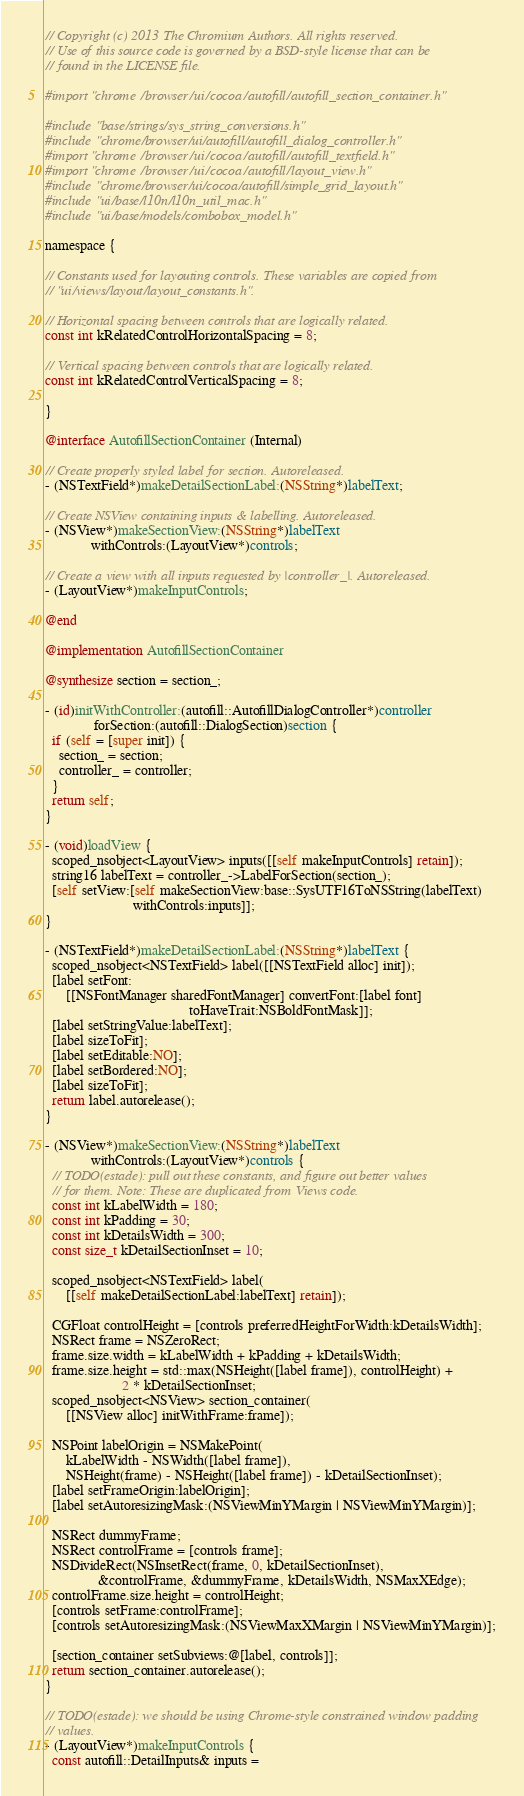Convert code to text. <code><loc_0><loc_0><loc_500><loc_500><_ObjectiveC_>// Copyright (c) 2013 The Chromium Authors. All rights reserved.
// Use of this source code is governed by a BSD-style license that can be
// found in the LICENSE file.

#import "chrome/browser/ui/cocoa/autofill/autofill_section_container.h"

#include "base/strings/sys_string_conversions.h"
#include "chrome/browser/ui/autofill/autofill_dialog_controller.h"
#import "chrome/browser/ui/cocoa/autofill/autofill_textfield.h"
#import "chrome/browser/ui/cocoa/autofill/layout_view.h"
#include "chrome/browser/ui/cocoa/autofill/simple_grid_layout.h"
#include "ui/base/l10n/l10n_util_mac.h"
#include "ui/base/models/combobox_model.h"

namespace {

// Constants used for layouting controls. These variables are copied from
// "ui/views/layout/layout_constants.h".

// Horizontal spacing between controls that are logically related.
const int kRelatedControlHorizontalSpacing = 8;

// Vertical spacing between controls that are logically related.
const int kRelatedControlVerticalSpacing = 8;

}

@interface AutofillSectionContainer (Internal)

// Create properly styled label for section. Autoreleased.
- (NSTextField*)makeDetailSectionLabel:(NSString*)labelText;

// Create NSView containing inputs & labelling. Autoreleased.
- (NSView*)makeSectionView:(NSString*)labelText
             withControls:(LayoutView*)controls;

// Create a view with all inputs requested by |controller_|. Autoreleased.
- (LayoutView*)makeInputControls;

@end

@implementation AutofillSectionContainer

@synthesize section = section_;

- (id)initWithController:(autofill::AutofillDialogController*)controller
              forSection:(autofill::DialogSection)section {
  if (self = [super init]) {
    section_ = section;
    controller_ = controller;
  }
  return self;
}

- (void)loadView {
  scoped_nsobject<LayoutView> inputs([[self makeInputControls] retain]);
  string16 labelText = controller_->LabelForSection(section_);
  [self setView:[self makeSectionView:base::SysUTF16ToNSString(labelText)
                         withControls:inputs]];
}

- (NSTextField*)makeDetailSectionLabel:(NSString*)labelText {
  scoped_nsobject<NSTextField> label([[NSTextField alloc] init]);
  [label setFont:
      [[NSFontManager sharedFontManager] convertFont:[label font]
                                         toHaveTrait:NSBoldFontMask]];
  [label setStringValue:labelText];
  [label sizeToFit];
  [label setEditable:NO];
  [label setBordered:NO];
  [label sizeToFit];
  return label.autorelease();
}

- (NSView*)makeSectionView:(NSString*)labelText
             withControls:(LayoutView*)controls {
  // TODO(estade): pull out these constants, and figure out better values
  // for them. Note: These are duplicated from Views code.
  const int kLabelWidth = 180;
  const int kPadding = 30;
  const int kDetailsWidth = 300;
  const size_t kDetailSectionInset = 10;

  scoped_nsobject<NSTextField> label(
      [[self makeDetailSectionLabel:labelText] retain]);

  CGFloat controlHeight = [controls preferredHeightForWidth:kDetailsWidth];
  NSRect frame = NSZeroRect;
  frame.size.width = kLabelWidth + kPadding + kDetailsWidth;
  frame.size.height = std::max(NSHeight([label frame]), controlHeight) +
                      2 * kDetailSectionInset;
  scoped_nsobject<NSView> section_container(
      [[NSView alloc] initWithFrame:frame]);

  NSPoint labelOrigin = NSMakePoint(
      kLabelWidth - NSWidth([label frame]),
      NSHeight(frame) - NSHeight([label frame]) - kDetailSectionInset);
  [label setFrameOrigin:labelOrigin];
  [label setAutoresizingMask:(NSViewMinYMargin | NSViewMinYMargin)];

  NSRect dummyFrame;
  NSRect controlFrame = [controls frame];
  NSDivideRect(NSInsetRect(frame, 0, kDetailSectionInset),
               &controlFrame, &dummyFrame, kDetailsWidth, NSMaxXEdge);
  controlFrame.size.height = controlHeight;
  [controls setFrame:controlFrame];
  [controls setAutoresizingMask:(NSViewMaxXMargin | NSViewMinYMargin)];

  [section_container setSubviews:@[label, controls]];
  return section_container.autorelease();
}

// TODO(estade): we should be using Chrome-style constrained window padding
// values.
- (LayoutView*)makeInputControls {
  const autofill::DetailInputs& inputs =</code> 